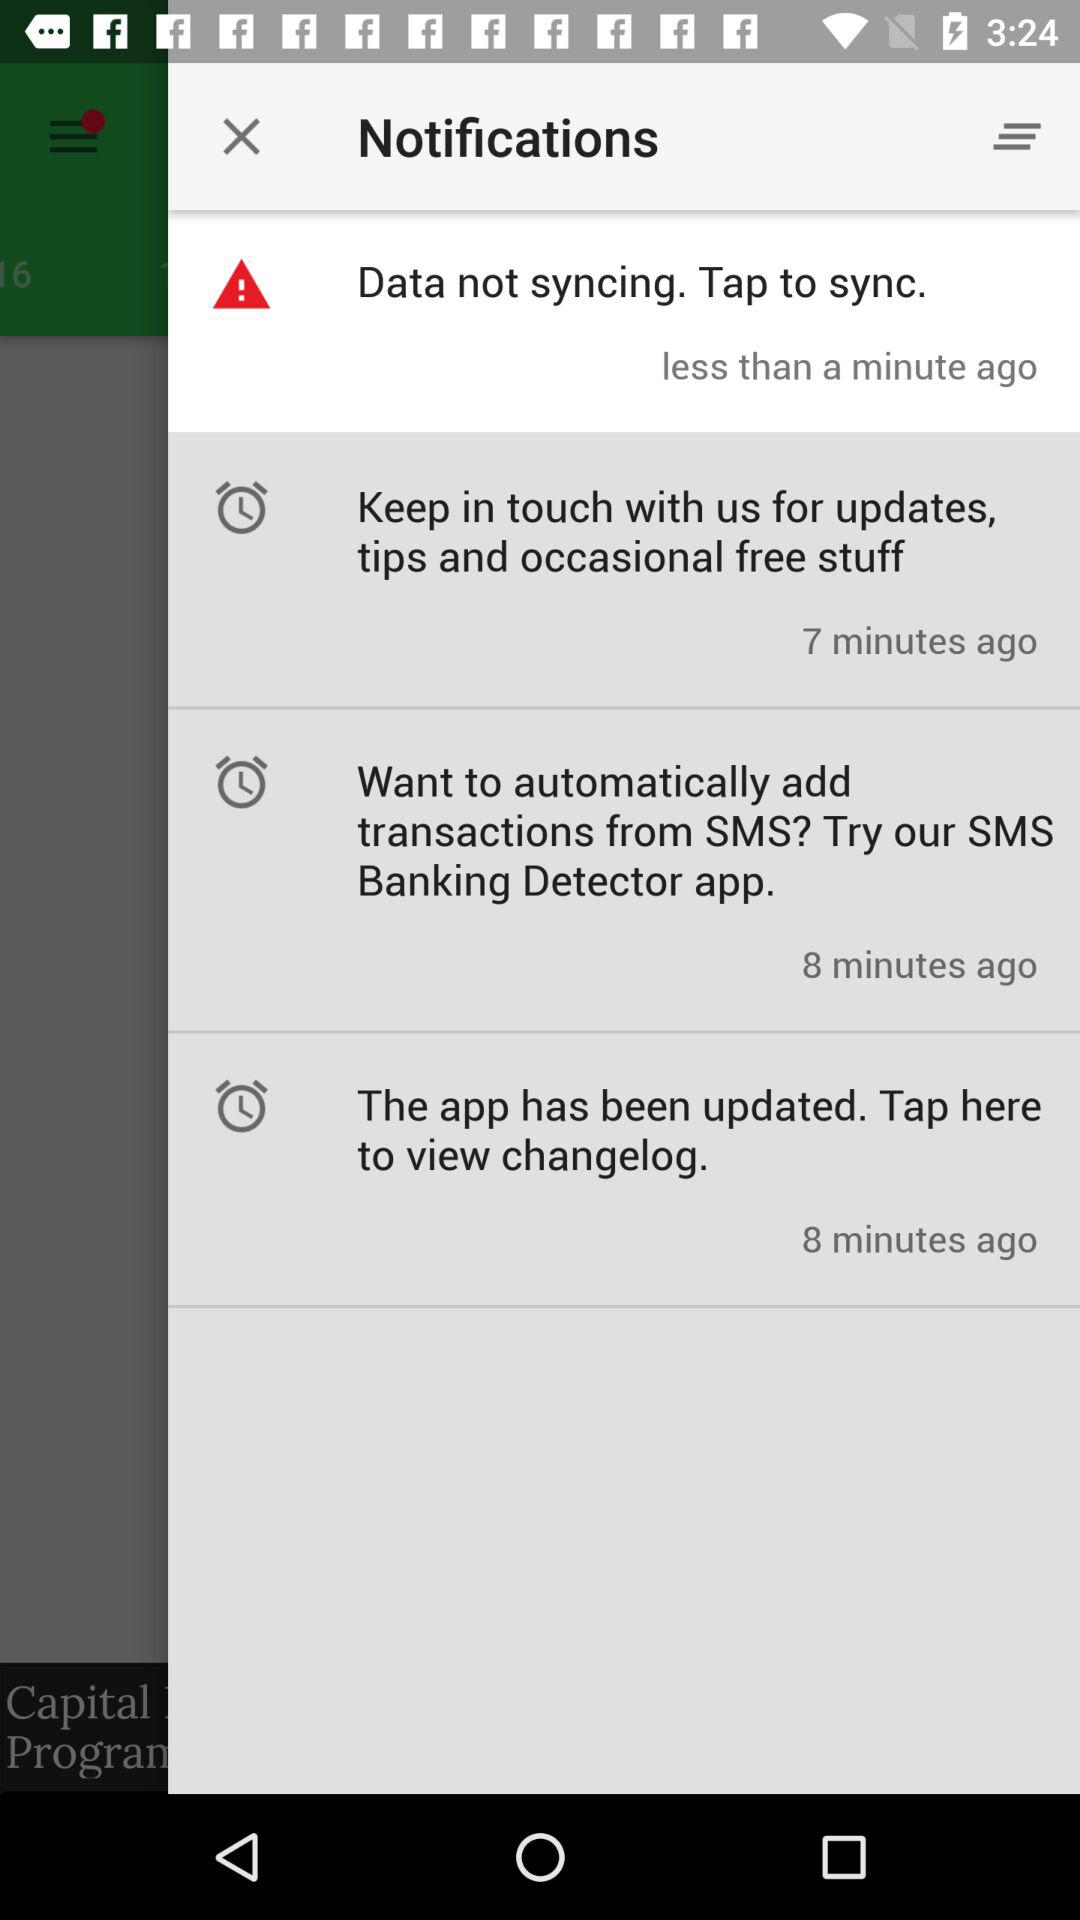How many notifications are there?
Answer the question using a single word or phrase. 4 